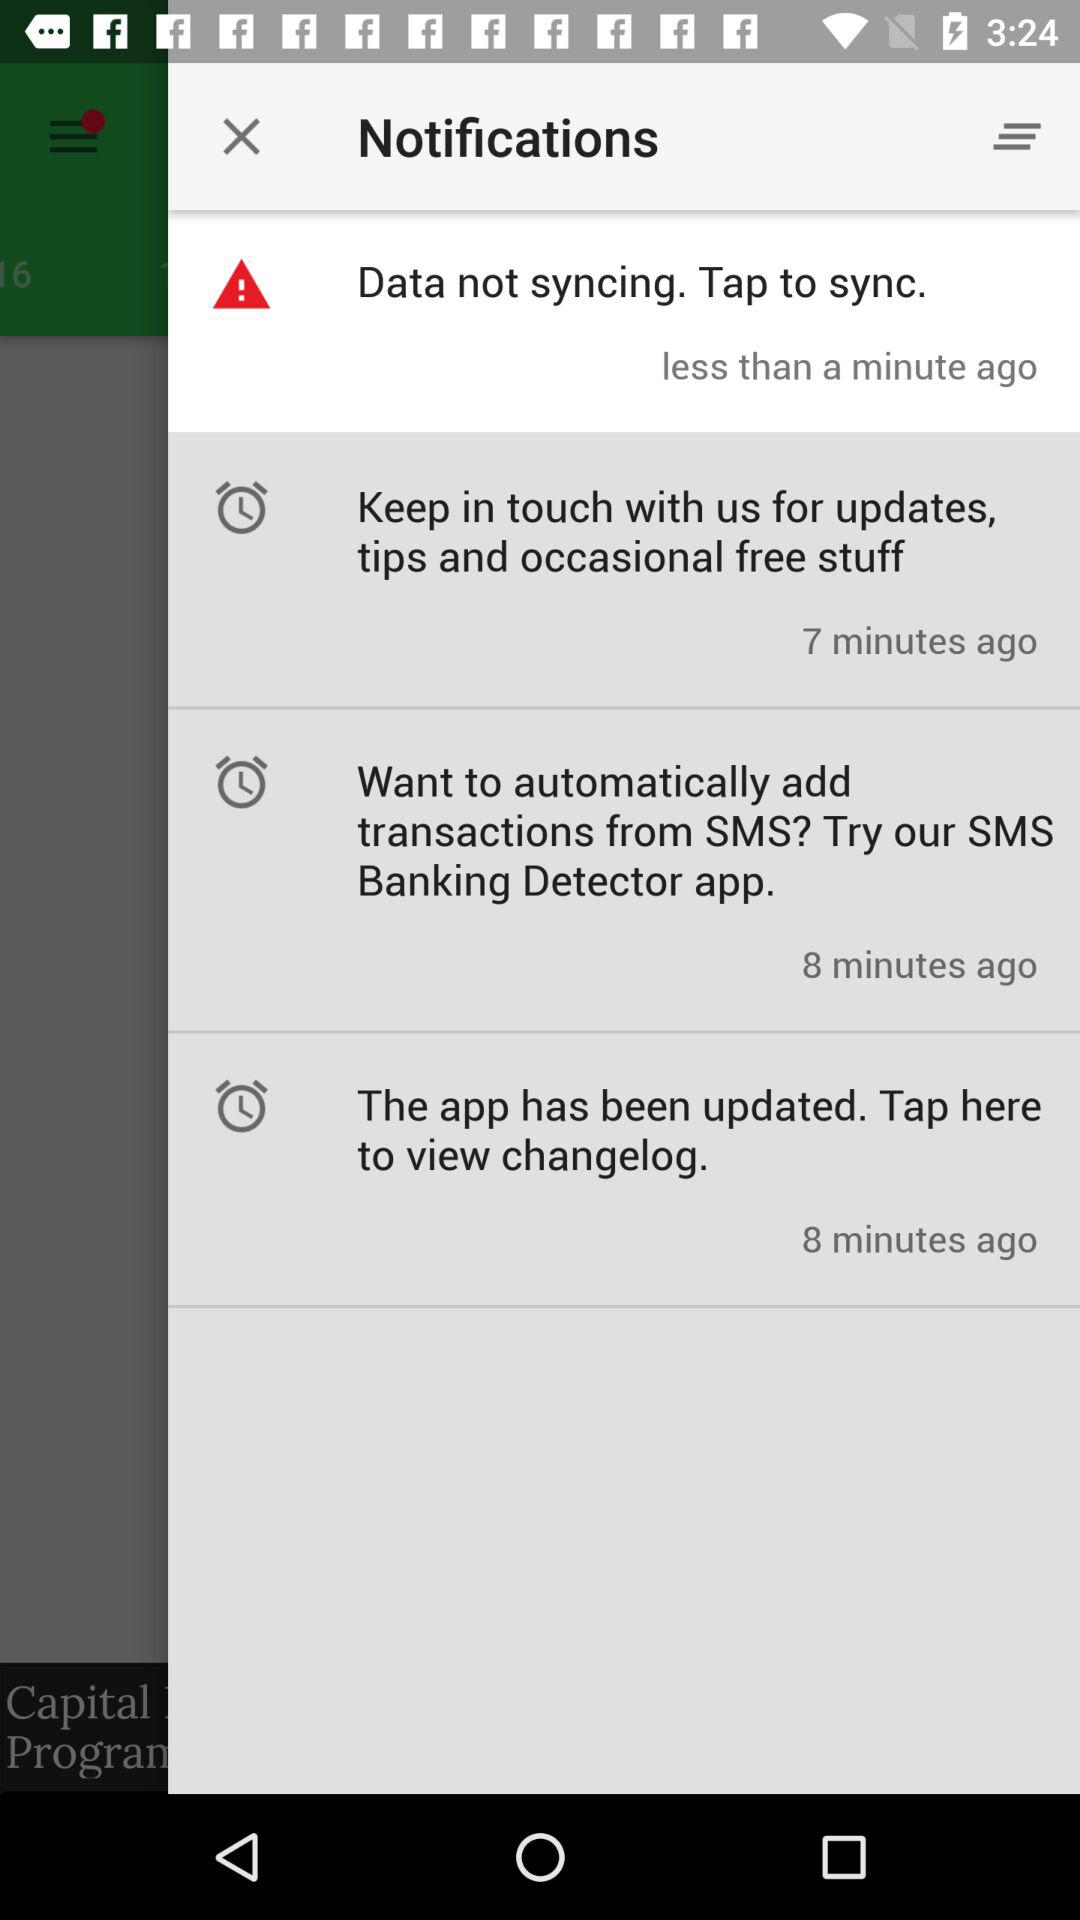How many notifications are there?
Answer the question using a single word or phrase. 4 